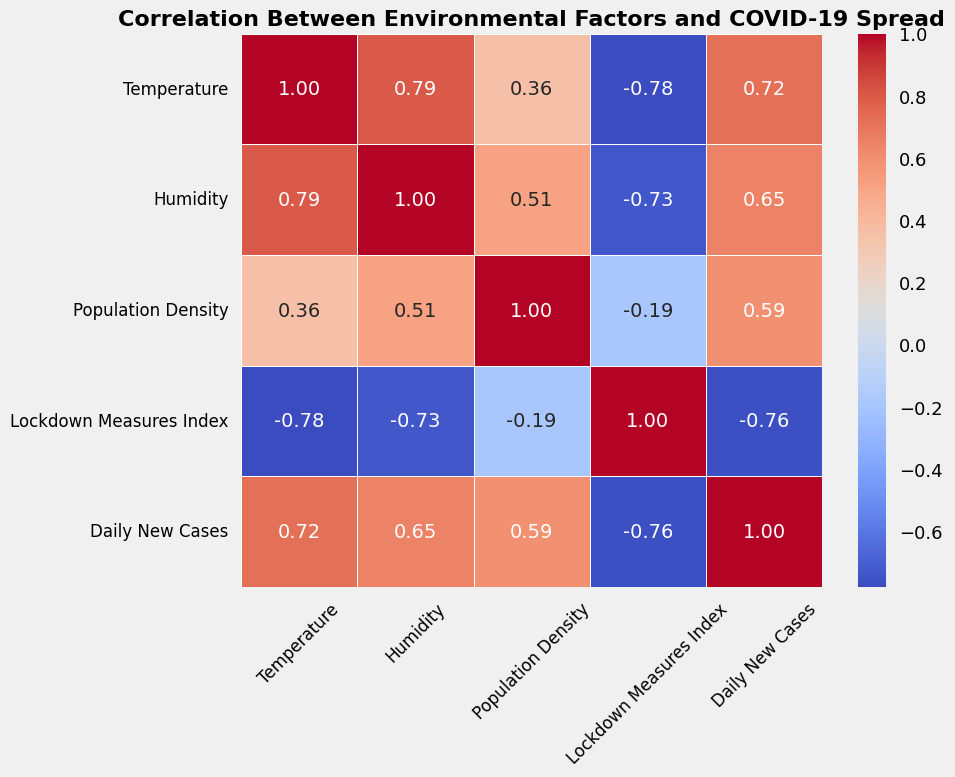What factor has the highest correlation with Daily New Cases? Look for the highest value in the Daily New Cases column in the heatmap. The highest correlation value is with Population Density.
Answer: Population Density What is the correlation between Temperature and Daily New Cases? Locate the intersection of the Temperature row and the Daily New Cases column on the heatmap to find the correlation value. The value there is the correlation coefficient.
Answer: -0.52 Which two factors have the strongest negative correlation, and what is their correlation value? Search the heatmap for the most negative correlation value. Note its location and the corresponding factors. The most negative correlation is between Temperature and Humidity, with the value at their intersection being -0.95.
Answer: Temperature and Humidity, -0.95 How does the correlation between Population Density and Lockdown Measures Index compare to the correlation between Humidity and Lockdown Measures Index? Check the correlation values at the intersections of Population Density with Lockdown Measures Index and Humidity with Lockdown Measures Index on the heatmap. Compare these two values.
Answer: 0.42 (Population Density) vs. 0.08 (Humidity) Which environmental factor shows the least correlation with Daily New Cases? Identify the factor with the correlation value closest to 0 in the Daily New Cases column of the heatmap. The lowest correlation is shown by Temperature with a value of -0.52.
Answer: Temperature What is the average of the correlations between Humidity and other factors? Find all correlation values in the Humidity row/column and calculate their average: \((0.98 + -0.95 + 0.57 + 0.08 + -0.49)/5\). The total is \(0.19/5\).
Answer: 0.04 Are there any factors that exhibit a correlation value equal to 1 with any other factor? If so, what are they? Check if any values in the heatmap are exactly 1. The value 1 indicates a perfect positive correlation. Humidity shows a perfect positive correlation with Temperature.
Answer: Yes, Humidity and Temperature Which two factors' correlation is closest to zero, indicating the weakest linear relationship? Identify the value in the heatmap closest to zero and note its location, identifying the corresponding factors. The value closest to zero is between Humidity and Lockdown Measures Index, with a correlation of 0.08.
Answer: Humidity and Lockdown Measures Index How does the correlation between Temperature and Population Density compare to the correlation between Temperature and Lockdown Measures Index? Look for the intersection points in the heatmap to find the correlation values of Temperature with Population Density and Temperature with Lockdown Measures Index and compare them.
Answer: -0.22 (Population Density) vs. -0.07 (Lockdown Measures Index) What is the correlation between Humidity and Population Density, and how is it different from the correlation between Humidity and Temperature? Locate the correlation value between Humidity and Population Density in the heatmap, then check the correlation between Humidity and Temperature. The correlation between Humidity and Population Density is 0.57, and the correlation between Humidity and Temperature is 0.98.
Answer: 0.57, Humidity and Temperature correlation is higher at 0.98 